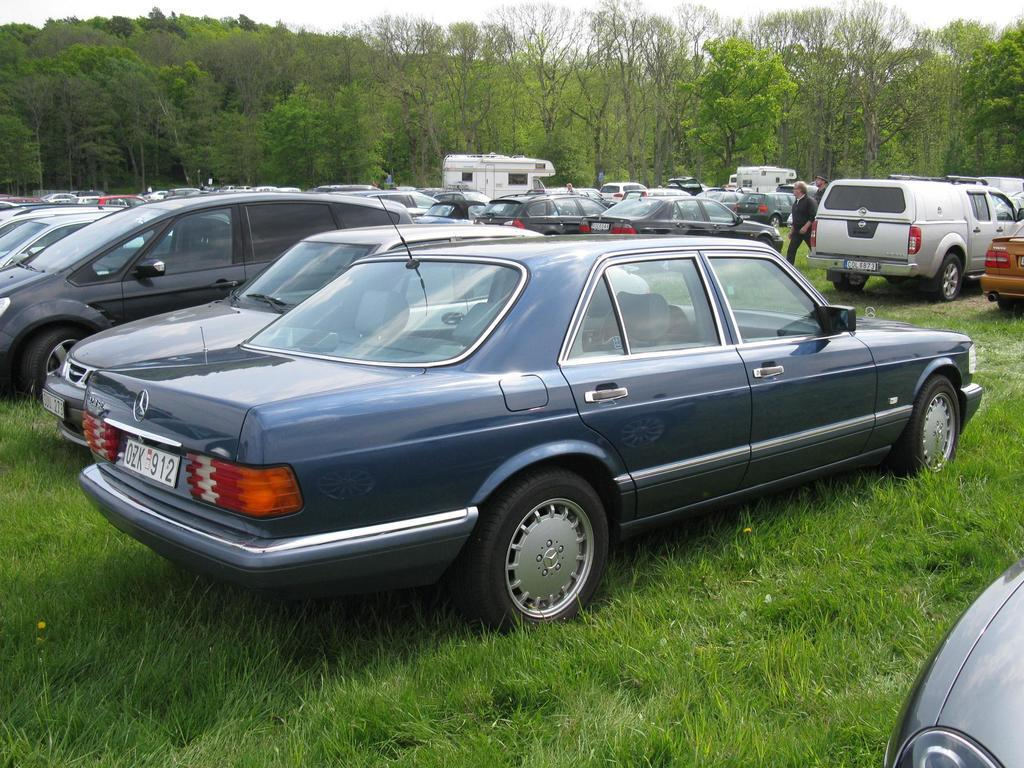<image>
Summarize the visual content of the image. a car with 912 on the back of the license plate 